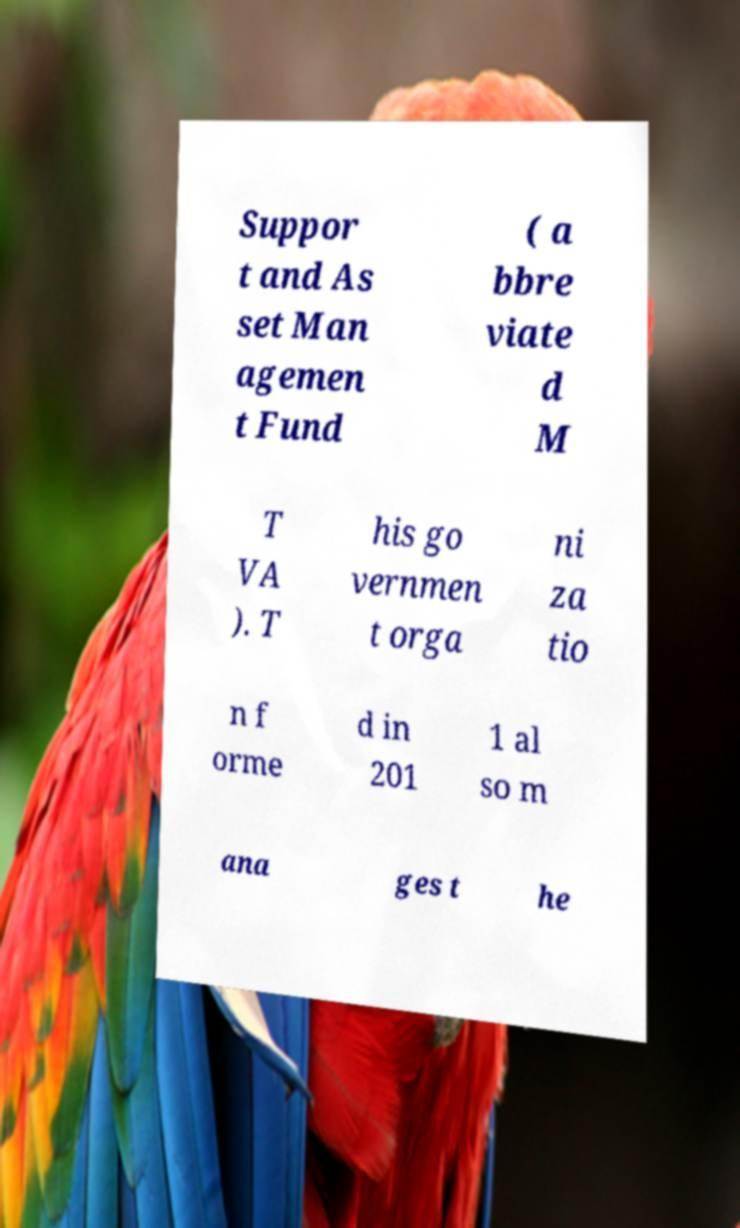I need the written content from this picture converted into text. Can you do that? Suppor t and As set Man agemen t Fund ( a bbre viate d M T VA ). T his go vernmen t orga ni za tio n f orme d in 201 1 al so m ana ges t he 